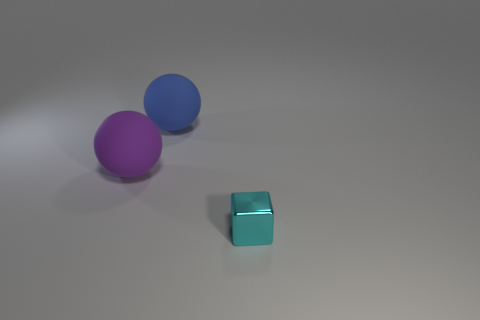What is the size of the rubber sphere that is behind the large rubber sphere that is left of the large blue rubber thing?
Provide a succinct answer. Large. Does the thing on the right side of the large blue ball have the same shape as the large thing that is on the left side of the large blue rubber ball?
Offer a very short reply. No. Are there an equal number of small metal objects that are in front of the shiny block and tiny cyan cubes?
Make the answer very short. No. What is the color of the other large matte object that is the same shape as the big blue object?
Offer a very short reply. Purple. Is the material of the object that is behind the purple matte ball the same as the tiny cyan cube?
Your response must be concise. No. What number of large things are cyan shiny blocks or matte spheres?
Provide a short and direct response. 2. How big is the purple thing?
Provide a short and direct response. Large. Do the metal cube and the thing that is behind the purple thing have the same size?
Ensure brevity in your answer.  No. What number of purple things are shiny things or small metal spheres?
Your answer should be very brief. 0. How many big purple blocks are there?
Your answer should be compact. 0. 